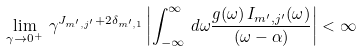<formula> <loc_0><loc_0><loc_500><loc_500>\lim _ { \gamma \rightarrow 0 ^ { + } } \, \gamma ^ { J _ { m ^ { \prime } , j ^ { \prime } } + 2 \delta _ { m ^ { \prime } , 1 } } \left | \int ^ { \infty } _ { - \infty } \, d \omega \frac { g ( \omega ) \, I _ { m ^ { \prime } , j ^ { \prime } } ( \omega ) } { ( \omega - \alpha ) } \right | < \infty</formula> 